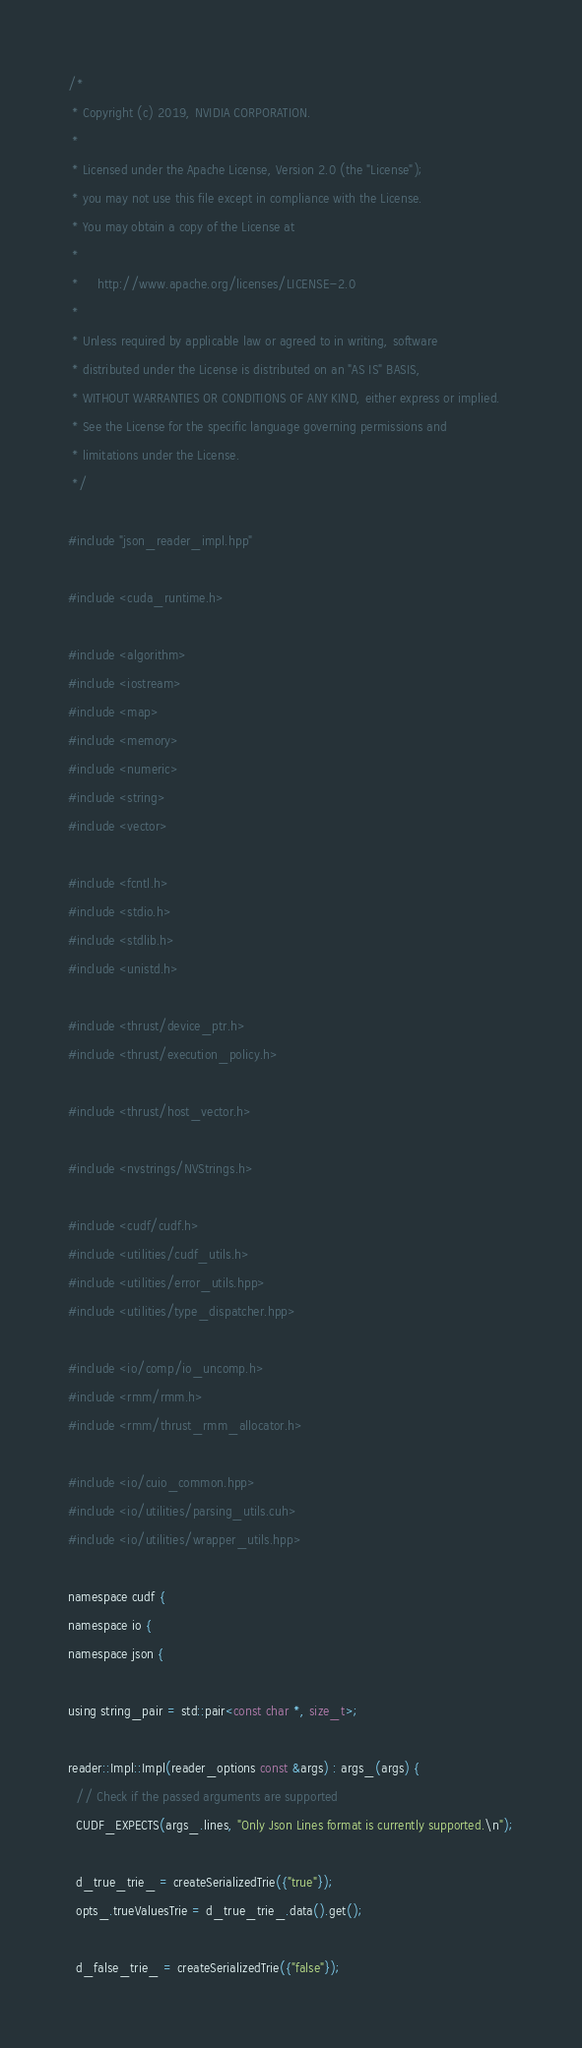Convert code to text. <code><loc_0><loc_0><loc_500><loc_500><_Cuda_>/*
 * Copyright (c) 2019, NVIDIA CORPORATION.
 *
 * Licensed under the Apache License, Version 2.0 (the "License");
 * you may not use this file except in compliance with the License.
 * You may obtain a copy of the License at
 *
 *     http://www.apache.org/licenses/LICENSE-2.0
 *
 * Unless required by applicable law or agreed to in writing, software
 * distributed under the License is distributed on an "AS IS" BASIS,
 * WITHOUT WARRANTIES OR CONDITIONS OF ANY KIND, either express or implied.
 * See the License for the specific language governing permissions and
 * limitations under the License.
 */

#include "json_reader_impl.hpp"

#include <cuda_runtime.h>

#include <algorithm>
#include <iostream>
#include <map>
#include <memory>
#include <numeric>
#include <string>
#include <vector>

#include <fcntl.h>
#include <stdio.h>
#include <stdlib.h>
#include <unistd.h>

#include <thrust/device_ptr.h>
#include <thrust/execution_policy.h>

#include <thrust/host_vector.h>

#include <nvstrings/NVStrings.h>

#include <cudf/cudf.h>
#include <utilities/cudf_utils.h>
#include <utilities/error_utils.hpp>
#include <utilities/type_dispatcher.hpp>

#include <io/comp/io_uncomp.h>
#include <rmm/rmm.h>
#include <rmm/thrust_rmm_allocator.h>

#include <io/cuio_common.hpp>
#include <io/utilities/parsing_utils.cuh>
#include <io/utilities/wrapper_utils.hpp>

namespace cudf {
namespace io {
namespace json {

using string_pair = std::pair<const char *, size_t>;

reader::Impl::Impl(reader_options const &args) : args_(args) {
  // Check if the passed arguments are supported
  CUDF_EXPECTS(args_.lines, "Only Json Lines format is currently supported.\n");

  d_true_trie_ = createSerializedTrie({"true"});
  opts_.trueValuesTrie = d_true_trie_.data().get();

  d_false_trie_ = createSerializedTrie({"false"});</code> 